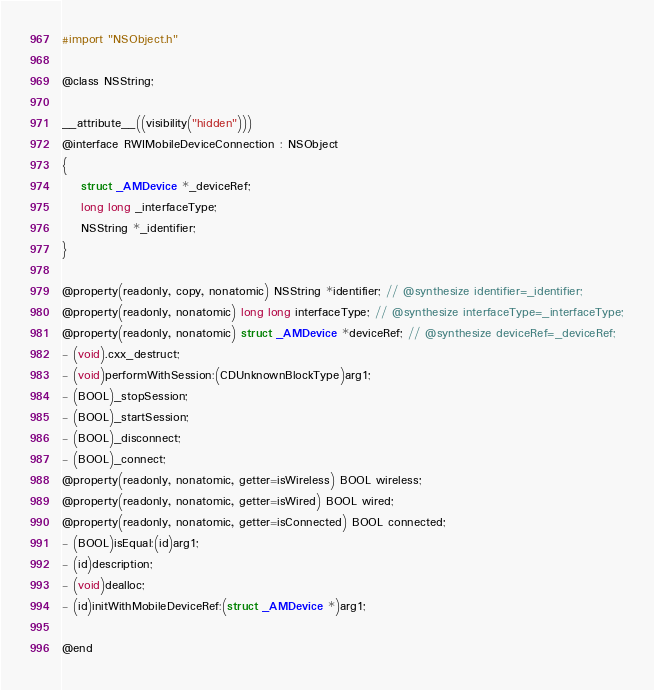<code> <loc_0><loc_0><loc_500><loc_500><_C_>
#import "NSObject.h"

@class NSString;

__attribute__((visibility("hidden")))
@interface RWIMobileDeviceConnection : NSObject
{
    struct _AMDevice *_deviceRef;
    long long _interfaceType;
    NSString *_identifier;
}

@property(readonly, copy, nonatomic) NSString *identifier; // @synthesize identifier=_identifier;
@property(readonly, nonatomic) long long interfaceType; // @synthesize interfaceType=_interfaceType;
@property(readonly, nonatomic) struct _AMDevice *deviceRef; // @synthesize deviceRef=_deviceRef;
- (void).cxx_destruct;
- (void)performWithSession:(CDUnknownBlockType)arg1;
- (BOOL)_stopSession;
- (BOOL)_startSession;
- (BOOL)_disconnect;
- (BOOL)_connect;
@property(readonly, nonatomic, getter=isWireless) BOOL wireless;
@property(readonly, nonatomic, getter=isWired) BOOL wired;
@property(readonly, nonatomic, getter=isConnected) BOOL connected;
- (BOOL)isEqual:(id)arg1;
- (id)description;
- (void)dealloc;
- (id)initWithMobileDeviceRef:(struct _AMDevice *)arg1;

@end

</code> 